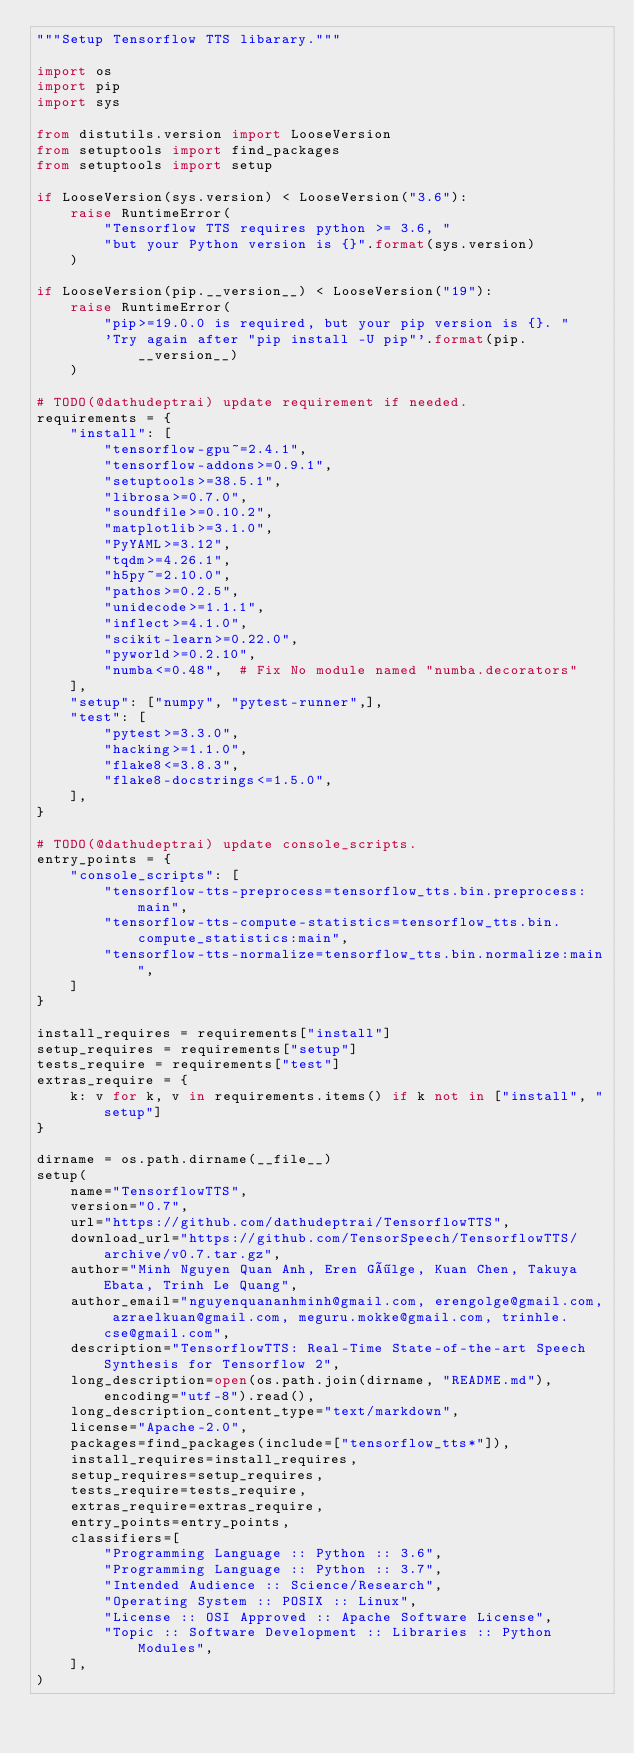<code> <loc_0><loc_0><loc_500><loc_500><_Python_>"""Setup Tensorflow TTS libarary."""

import os
import pip
import sys

from distutils.version import LooseVersion
from setuptools import find_packages
from setuptools import setup

if LooseVersion(sys.version) < LooseVersion("3.6"):
    raise RuntimeError(
        "Tensorflow TTS requires python >= 3.6, "
        "but your Python version is {}".format(sys.version)
    )

if LooseVersion(pip.__version__) < LooseVersion("19"):
    raise RuntimeError(
        "pip>=19.0.0 is required, but your pip version is {}. "
        'Try again after "pip install -U pip"'.format(pip.__version__)
    )

# TODO(@dathudeptrai) update requirement if needed.
requirements = {
    "install": [
        "tensorflow-gpu~=2.4.1",
        "tensorflow-addons>=0.9.1",
        "setuptools>=38.5.1",
        "librosa>=0.7.0",
        "soundfile>=0.10.2",
        "matplotlib>=3.1.0",
        "PyYAML>=3.12",
        "tqdm>=4.26.1",
        "h5py~=2.10.0",
        "pathos>=0.2.5",
        "unidecode>=1.1.1",
        "inflect>=4.1.0",
        "scikit-learn>=0.22.0",
        "pyworld>=0.2.10",
        "numba<=0.48",  # Fix No module named "numba.decorators"
    ],
    "setup": ["numpy", "pytest-runner",],
    "test": [
        "pytest>=3.3.0",
        "hacking>=1.1.0",
        "flake8<=3.8.3",
        "flake8-docstrings<=1.5.0",
    ],
}

# TODO(@dathudeptrai) update console_scripts.
entry_points = {
    "console_scripts": [
        "tensorflow-tts-preprocess=tensorflow_tts.bin.preprocess:main",
        "tensorflow-tts-compute-statistics=tensorflow_tts.bin.compute_statistics:main",
        "tensorflow-tts-normalize=tensorflow_tts.bin.normalize:main",
    ]
}

install_requires = requirements["install"]
setup_requires = requirements["setup"]
tests_require = requirements["test"]
extras_require = {
    k: v for k, v in requirements.items() if k not in ["install", "setup"]
}

dirname = os.path.dirname(__file__)
setup(
    name="TensorflowTTS",
    version="0.7",
    url="https://github.com/dathudeptrai/TensorflowTTS",
    download_url="https://github.com/TensorSpeech/TensorflowTTS/archive/v0.7.tar.gz",
    author="Minh Nguyen Quan Anh, Eren Gölge, Kuan Chen, Takuya Ebata, Trinh Le Quang",
    author_email="nguyenquananhminh@gmail.com, erengolge@gmail.com, azraelkuan@gmail.com, meguru.mokke@gmail.com, trinhle.cse@gmail.com",
    description="TensorflowTTS: Real-Time State-of-the-art Speech Synthesis for Tensorflow 2",
    long_description=open(os.path.join(dirname, "README.md"), encoding="utf-8").read(),
    long_description_content_type="text/markdown",
    license="Apache-2.0",
    packages=find_packages(include=["tensorflow_tts*"]),
    install_requires=install_requires,
    setup_requires=setup_requires,
    tests_require=tests_require,
    extras_require=extras_require,
    entry_points=entry_points,
    classifiers=[
        "Programming Language :: Python :: 3.6",
        "Programming Language :: Python :: 3.7",
        "Intended Audience :: Science/Research",
        "Operating System :: POSIX :: Linux",
        "License :: OSI Approved :: Apache Software License",
        "Topic :: Software Development :: Libraries :: Python Modules",
    ],
)</code> 